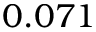<formula> <loc_0><loc_0><loc_500><loc_500>0 . 0 7 1</formula> 